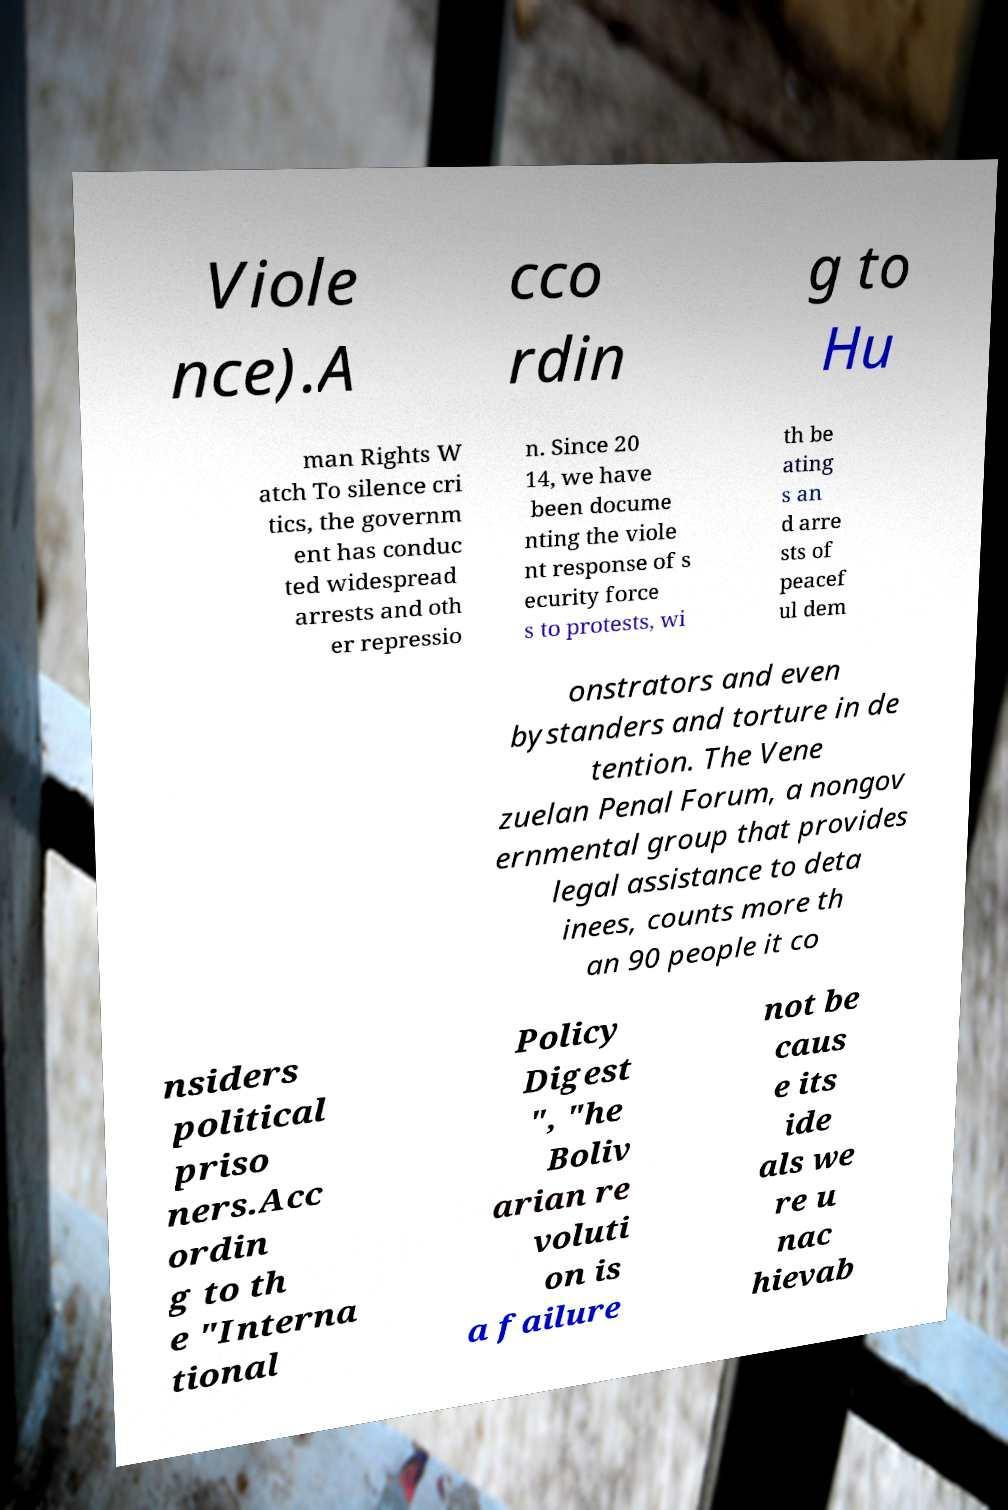Can you read and provide the text displayed in the image?This photo seems to have some interesting text. Can you extract and type it out for me? Viole nce).A cco rdin g to Hu man Rights W atch To silence cri tics, the governm ent has conduc ted widespread arrests and oth er repressio n. Since 20 14, we have been docume nting the viole nt response of s ecurity force s to protests, wi th be ating s an d arre sts of peacef ul dem onstrators and even bystanders and torture in de tention. The Vene zuelan Penal Forum, a nongov ernmental group that provides legal assistance to deta inees, counts more th an 90 people it co nsiders political priso ners.Acc ordin g to th e "Interna tional Policy Digest ", "he Boliv arian re voluti on is a failure not be caus e its ide als we re u nac hievab 